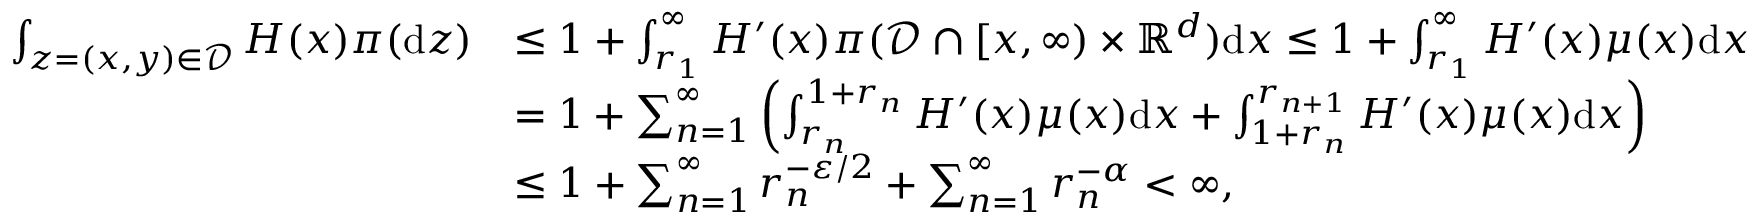<formula> <loc_0><loc_0><loc_500><loc_500>\begin{array} { r l } { \int _ { z = ( x , y ) \in { \mathcal { D } } } H ( x ) \pi ( { \mathrm d } z ) } & { \leq 1 + \int _ { r _ { 1 } } ^ { \infty } H ^ { \prime } ( x ) \pi ( { \mathcal { D } } \cap [ x , \infty ) \times { \mathbb { R } } ^ { d } ) { \mathrm d } x \leq 1 + \int _ { r _ { 1 } } ^ { \infty } H ^ { \prime } ( x ) \mu ( x ) { \mathrm d } x } \\ & { = 1 + \sum _ { n = 1 } ^ { \infty } \left ( \int _ { r _ { n } } ^ { 1 + r _ { n } } H ^ { \prime } ( x ) \mu ( x ) { \mathrm d } x + \int _ { 1 + r _ { n } } ^ { r _ { n + 1 } } H ^ { \prime } ( x ) \mu ( x ) { \mathrm d } x \right ) } \\ & { \leq 1 + \sum _ { n = 1 } ^ { \infty } r _ { n } ^ { - \varepsilon / 2 } + \sum _ { n = 1 } ^ { \infty } r _ { n } ^ { - \alpha } < \infty , } \end{array}</formula> 